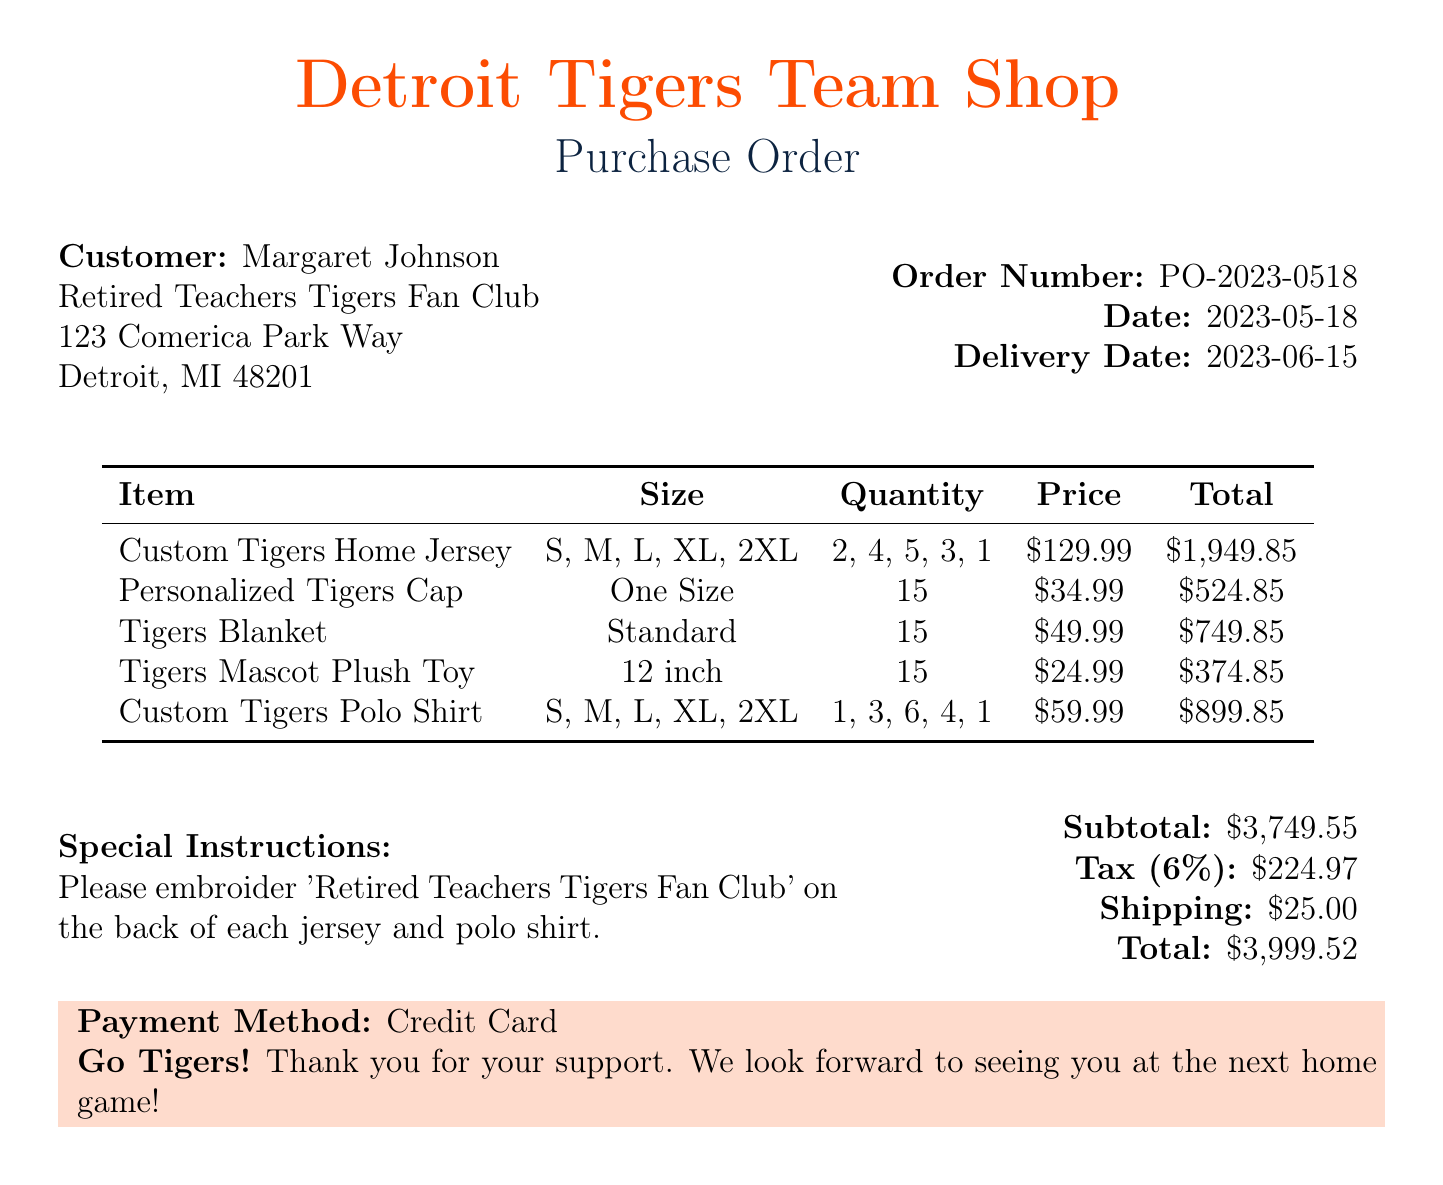What is the order number? The order number is listed at the top of the document.
Answer: PO-2023-0518 What is the delivery date? The delivery date is stated in the order details section of the document.
Answer: 2023-06-15 Who is the customer? The customer's name is provided in the document under the customer section.
Answer: Margaret Johnson What is the quantity of Custom Tigers Home Jerseys ordered? The quantity is specified within the items listed in the document.
Answer: 15 What is the price per unit of the Personalized Tigers Cap? The price for this item is shown next to the item description.
Answer: 34.99 What special instructions are given? The special instructions are included in a specific section of the document.
Answer: Please embroider 'Retired Teachers Tigers Fan Club' on the back of each jersey and polo shirt What is the subtotal for the order? The subtotal is mentioned in the summary of the document's financial details.
Answer: 3749.55 How many different items are ordered? The number of items can be counted from the items list within the document.
Answer: 5 What organization is the customer group associated with? The customer group is identified in the customer information section of the document.
Answer: Retired Teachers Tigers Fan Club 